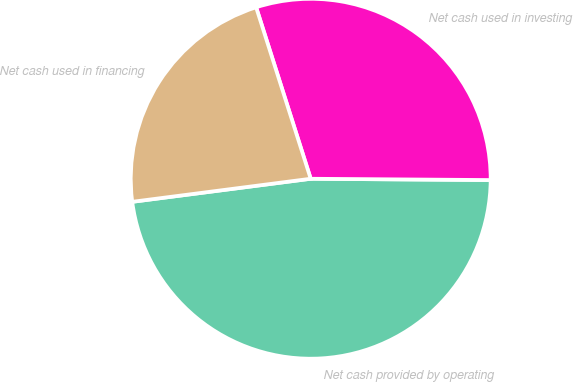Convert chart to OTSL. <chart><loc_0><loc_0><loc_500><loc_500><pie_chart><fcel>Net cash provided by operating<fcel>Net cash used in investing<fcel>Net cash used in financing<nl><fcel>47.84%<fcel>30.02%<fcel>22.14%<nl></chart> 